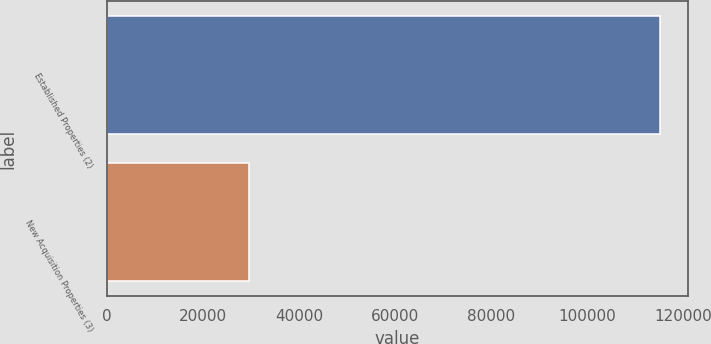<chart> <loc_0><loc_0><loc_500><loc_500><bar_chart><fcel>Established Properties (2)<fcel>New Acquisition Properties (3)<nl><fcel>115152<fcel>29512<nl></chart> 